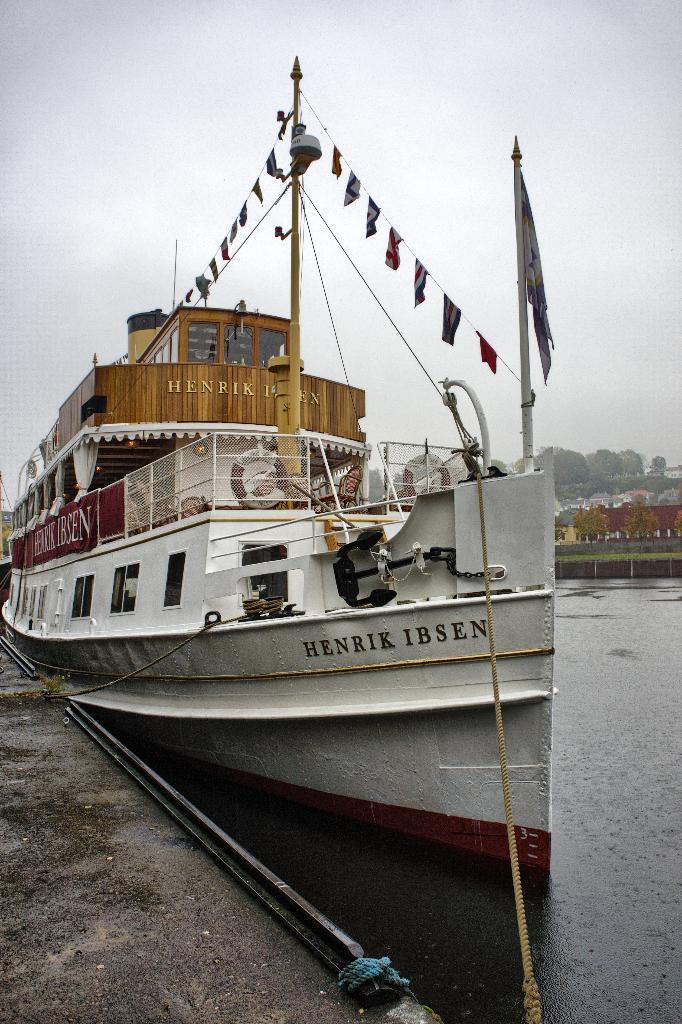Describe this image in one or two sentences. In the foreground I can see a boat in the water, ribbons, ropes, flag pole, fence, water, trees, buildings, bridge and the sky. This image is taken may be during a day. 